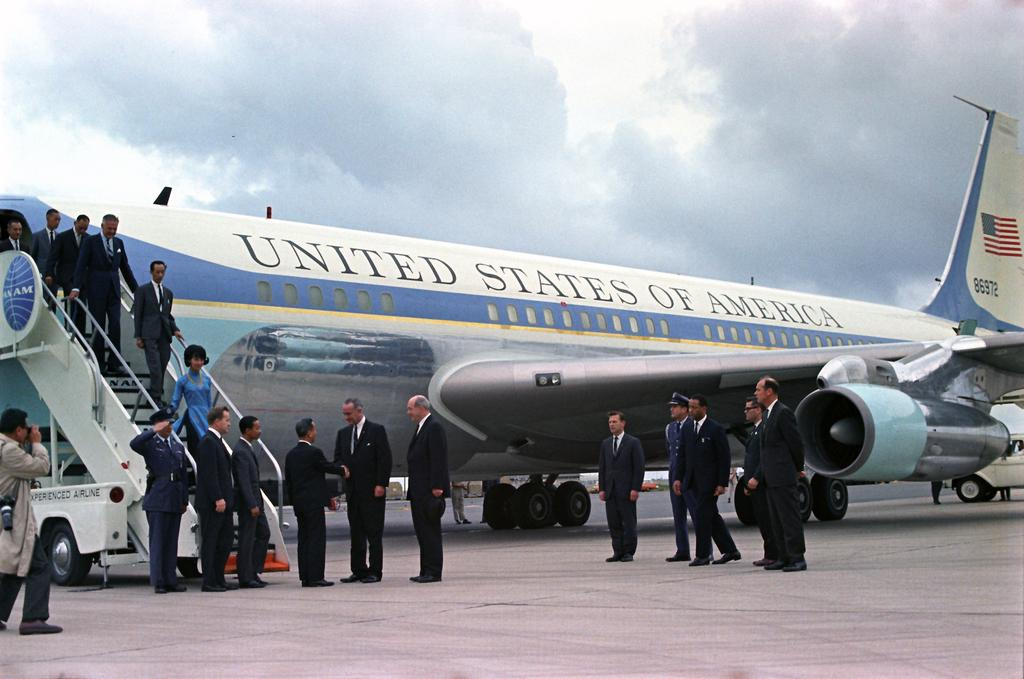Provide a one-sentence caption for the provided image. A picture of the united states of america air force one. 